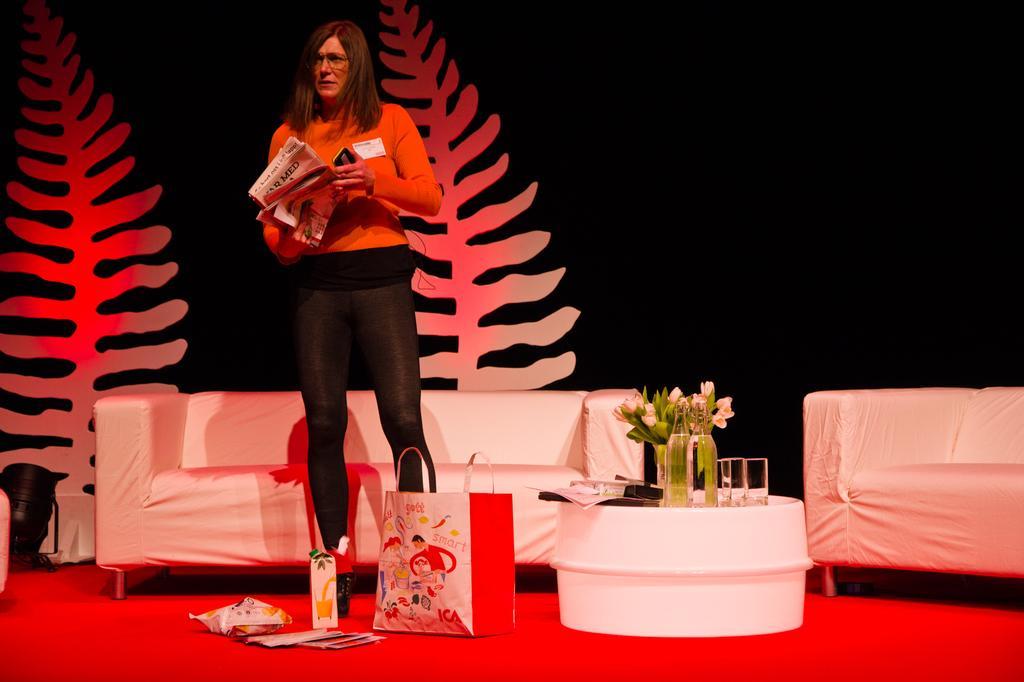Could you give a brief overview of what you see in this image? This picture describes about a standing woman, she is holding a news paper and a mobile in her hand, in front of her we can see a bag and bottle, and also we can see a flower vase, bottles, glasses on the table. 